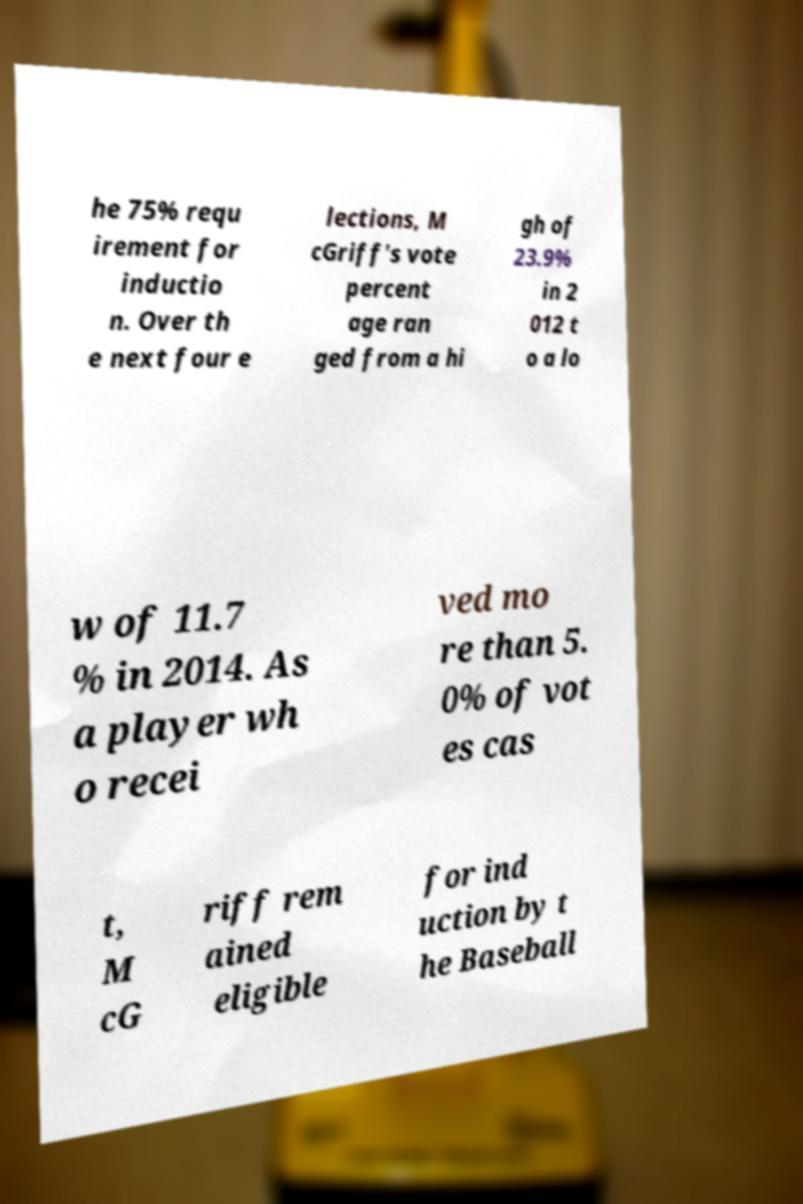Please identify and transcribe the text found in this image. he 75% requ irement for inductio n. Over th e next four e lections, M cGriff's vote percent age ran ged from a hi gh of 23.9% in 2 012 t o a lo w of 11.7 % in 2014. As a player wh o recei ved mo re than 5. 0% of vot es cas t, M cG riff rem ained eligible for ind uction by t he Baseball 